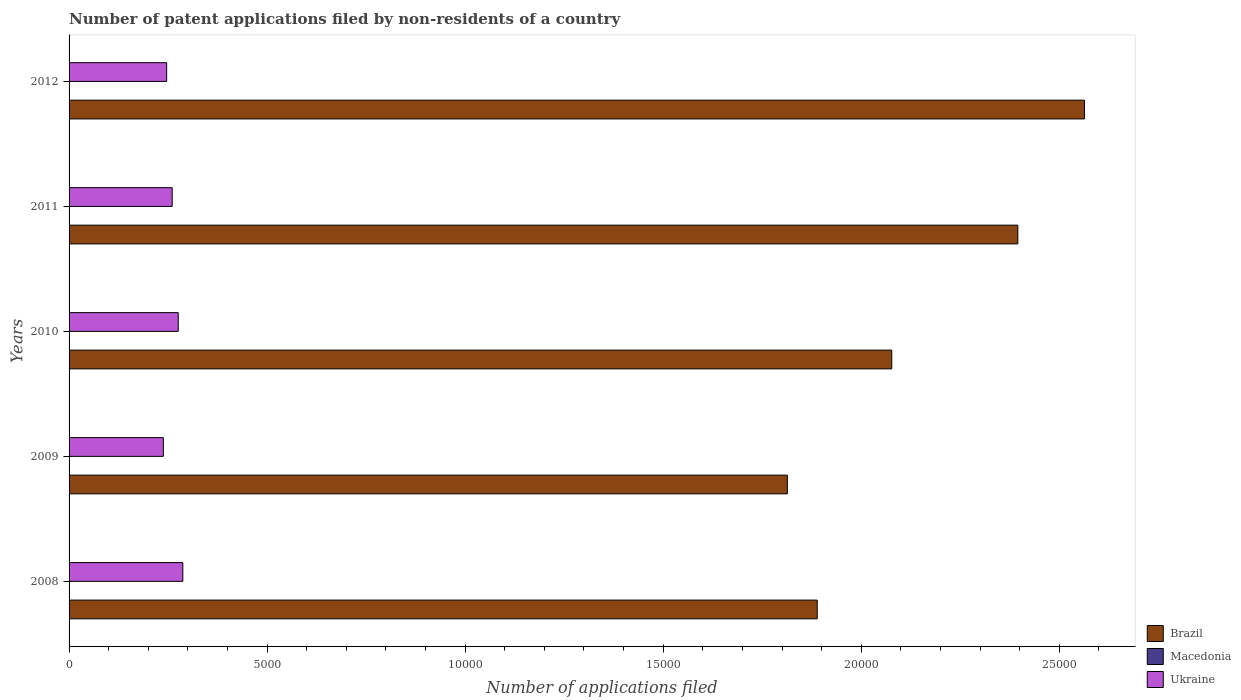How many groups of bars are there?
Provide a short and direct response. 5. How many bars are there on the 2nd tick from the bottom?
Give a very brief answer. 3. What is the label of the 2nd group of bars from the top?
Ensure brevity in your answer.  2011. In how many cases, is the number of bars for a given year not equal to the number of legend labels?
Keep it short and to the point. 0. What is the number of applications filed in Ukraine in 2009?
Offer a terse response. 2380. Across all years, what is the maximum number of applications filed in Ukraine?
Your answer should be very brief. 2872. In which year was the number of applications filed in Brazil maximum?
Give a very brief answer. 2012. In which year was the number of applications filed in Brazil minimum?
Your answer should be very brief. 2009. What is the difference between the number of applications filed in Ukraine in 2009 and that in 2011?
Ensure brevity in your answer.  -224. What is the difference between the number of applications filed in Ukraine in 2010 and the number of applications filed in Macedonia in 2011?
Your response must be concise. 2753. What is the average number of applications filed in Ukraine per year?
Offer a terse response. 2615.2. In the year 2009, what is the difference between the number of applications filed in Macedonia and number of applications filed in Brazil?
Provide a succinct answer. -1.81e+04. In how many years, is the number of applications filed in Ukraine greater than 10000 ?
Provide a succinct answer. 0. What is the ratio of the number of applications filed in Macedonia in 2008 to that in 2012?
Provide a short and direct response. 1.67. Is the sum of the number of applications filed in Macedonia in 2008 and 2011 greater than the maximum number of applications filed in Brazil across all years?
Keep it short and to the point. No. What does the 3rd bar from the top in 2011 represents?
Ensure brevity in your answer.  Brazil. What does the 2nd bar from the bottom in 2009 represents?
Give a very brief answer. Macedonia. Are all the bars in the graph horizontal?
Make the answer very short. Yes. Are the values on the major ticks of X-axis written in scientific E-notation?
Your answer should be very brief. No. Where does the legend appear in the graph?
Your response must be concise. Bottom right. How many legend labels are there?
Make the answer very short. 3. What is the title of the graph?
Provide a succinct answer. Number of patent applications filed by non-residents of a country. Does "Faeroe Islands" appear as one of the legend labels in the graph?
Make the answer very short. No. What is the label or title of the X-axis?
Your answer should be very brief. Number of applications filed. What is the Number of applications filed of Brazil in 2008?
Make the answer very short. 1.89e+04. What is the Number of applications filed in Macedonia in 2008?
Your answer should be very brief. 5. What is the Number of applications filed of Ukraine in 2008?
Your answer should be compact. 2872. What is the Number of applications filed of Brazil in 2009?
Your response must be concise. 1.81e+04. What is the Number of applications filed of Ukraine in 2009?
Provide a short and direct response. 2380. What is the Number of applications filed of Brazil in 2010?
Offer a very short reply. 2.08e+04. What is the Number of applications filed of Ukraine in 2010?
Provide a short and direct response. 2756. What is the Number of applications filed of Brazil in 2011?
Your answer should be compact. 2.40e+04. What is the Number of applications filed in Ukraine in 2011?
Offer a very short reply. 2604. What is the Number of applications filed in Brazil in 2012?
Provide a succinct answer. 2.56e+04. What is the Number of applications filed of Ukraine in 2012?
Your response must be concise. 2464. Across all years, what is the maximum Number of applications filed in Brazil?
Your response must be concise. 2.56e+04. Across all years, what is the maximum Number of applications filed in Macedonia?
Ensure brevity in your answer.  11. Across all years, what is the maximum Number of applications filed of Ukraine?
Ensure brevity in your answer.  2872. Across all years, what is the minimum Number of applications filed in Brazil?
Make the answer very short. 1.81e+04. Across all years, what is the minimum Number of applications filed of Ukraine?
Your answer should be compact. 2380. What is the total Number of applications filed of Brazil in the graph?
Offer a very short reply. 1.07e+05. What is the total Number of applications filed in Ukraine in the graph?
Ensure brevity in your answer.  1.31e+04. What is the difference between the Number of applications filed of Brazil in 2008 and that in 2009?
Ensure brevity in your answer.  755. What is the difference between the Number of applications filed of Macedonia in 2008 and that in 2009?
Ensure brevity in your answer.  -6. What is the difference between the Number of applications filed of Ukraine in 2008 and that in 2009?
Keep it short and to the point. 492. What is the difference between the Number of applications filed in Brazil in 2008 and that in 2010?
Provide a short and direct response. -1881. What is the difference between the Number of applications filed in Macedonia in 2008 and that in 2010?
Make the answer very short. 4. What is the difference between the Number of applications filed in Ukraine in 2008 and that in 2010?
Keep it short and to the point. 116. What is the difference between the Number of applications filed of Brazil in 2008 and that in 2011?
Offer a terse response. -5064. What is the difference between the Number of applications filed in Ukraine in 2008 and that in 2011?
Provide a succinct answer. 268. What is the difference between the Number of applications filed of Brazil in 2008 and that in 2012?
Provide a succinct answer. -6747. What is the difference between the Number of applications filed of Macedonia in 2008 and that in 2012?
Your response must be concise. 2. What is the difference between the Number of applications filed in Ukraine in 2008 and that in 2012?
Offer a terse response. 408. What is the difference between the Number of applications filed in Brazil in 2009 and that in 2010?
Provide a short and direct response. -2636. What is the difference between the Number of applications filed in Macedonia in 2009 and that in 2010?
Offer a very short reply. 10. What is the difference between the Number of applications filed of Ukraine in 2009 and that in 2010?
Offer a terse response. -376. What is the difference between the Number of applications filed of Brazil in 2009 and that in 2011?
Provide a short and direct response. -5819. What is the difference between the Number of applications filed of Ukraine in 2009 and that in 2011?
Keep it short and to the point. -224. What is the difference between the Number of applications filed in Brazil in 2009 and that in 2012?
Make the answer very short. -7502. What is the difference between the Number of applications filed in Ukraine in 2009 and that in 2012?
Provide a short and direct response. -84. What is the difference between the Number of applications filed in Brazil in 2010 and that in 2011?
Offer a very short reply. -3183. What is the difference between the Number of applications filed of Macedonia in 2010 and that in 2011?
Offer a very short reply. -2. What is the difference between the Number of applications filed of Ukraine in 2010 and that in 2011?
Your response must be concise. 152. What is the difference between the Number of applications filed in Brazil in 2010 and that in 2012?
Give a very brief answer. -4866. What is the difference between the Number of applications filed in Ukraine in 2010 and that in 2012?
Provide a short and direct response. 292. What is the difference between the Number of applications filed in Brazil in 2011 and that in 2012?
Make the answer very short. -1683. What is the difference between the Number of applications filed in Ukraine in 2011 and that in 2012?
Your response must be concise. 140. What is the difference between the Number of applications filed of Brazil in 2008 and the Number of applications filed of Macedonia in 2009?
Provide a short and direct response. 1.89e+04. What is the difference between the Number of applications filed in Brazil in 2008 and the Number of applications filed in Ukraine in 2009?
Ensure brevity in your answer.  1.65e+04. What is the difference between the Number of applications filed in Macedonia in 2008 and the Number of applications filed in Ukraine in 2009?
Your answer should be compact. -2375. What is the difference between the Number of applications filed of Brazil in 2008 and the Number of applications filed of Macedonia in 2010?
Keep it short and to the point. 1.89e+04. What is the difference between the Number of applications filed in Brazil in 2008 and the Number of applications filed in Ukraine in 2010?
Offer a very short reply. 1.61e+04. What is the difference between the Number of applications filed in Macedonia in 2008 and the Number of applications filed in Ukraine in 2010?
Ensure brevity in your answer.  -2751. What is the difference between the Number of applications filed in Brazil in 2008 and the Number of applications filed in Macedonia in 2011?
Your response must be concise. 1.89e+04. What is the difference between the Number of applications filed in Brazil in 2008 and the Number of applications filed in Ukraine in 2011?
Offer a very short reply. 1.63e+04. What is the difference between the Number of applications filed in Macedonia in 2008 and the Number of applications filed in Ukraine in 2011?
Provide a succinct answer. -2599. What is the difference between the Number of applications filed of Brazil in 2008 and the Number of applications filed of Macedonia in 2012?
Your answer should be very brief. 1.89e+04. What is the difference between the Number of applications filed in Brazil in 2008 and the Number of applications filed in Ukraine in 2012?
Provide a succinct answer. 1.64e+04. What is the difference between the Number of applications filed in Macedonia in 2008 and the Number of applications filed in Ukraine in 2012?
Ensure brevity in your answer.  -2459. What is the difference between the Number of applications filed of Brazil in 2009 and the Number of applications filed of Macedonia in 2010?
Offer a very short reply. 1.81e+04. What is the difference between the Number of applications filed in Brazil in 2009 and the Number of applications filed in Ukraine in 2010?
Your answer should be compact. 1.54e+04. What is the difference between the Number of applications filed in Macedonia in 2009 and the Number of applications filed in Ukraine in 2010?
Offer a very short reply. -2745. What is the difference between the Number of applications filed in Brazil in 2009 and the Number of applications filed in Macedonia in 2011?
Your response must be concise. 1.81e+04. What is the difference between the Number of applications filed of Brazil in 2009 and the Number of applications filed of Ukraine in 2011?
Offer a terse response. 1.55e+04. What is the difference between the Number of applications filed of Macedonia in 2009 and the Number of applications filed of Ukraine in 2011?
Provide a succinct answer. -2593. What is the difference between the Number of applications filed of Brazil in 2009 and the Number of applications filed of Macedonia in 2012?
Provide a succinct answer. 1.81e+04. What is the difference between the Number of applications filed of Brazil in 2009 and the Number of applications filed of Ukraine in 2012?
Make the answer very short. 1.57e+04. What is the difference between the Number of applications filed of Macedonia in 2009 and the Number of applications filed of Ukraine in 2012?
Ensure brevity in your answer.  -2453. What is the difference between the Number of applications filed of Brazil in 2010 and the Number of applications filed of Macedonia in 2011?
Keep it short and to the point. 2.08e+04. What is the difference between the Number of applications filed in Brazil in 2010 and the Number of applications filed in Ukraine in 2011?
Provide a short and direct response. 1.82e+04. What is the difference between the Number of applications filed of Macedonia in 2010 and the Number of applications filed of Ukraine in 2011?
Offer a terse response. -2603. What is the difference between the Number of applications filed of Brazil in 2010 and the Number of applications filed of Macedonia in 2012?
Offer a terse response. 2.08e+04. What is the difference between the Number of applications filed in Brazil in 2010 and the Number of applications filed in Ukraine in 2012?
Ensure brevity in your answer.  1.83e+04. What is the difference between the Number of applications filed in Macedonia in 2010 and the Number of applications filed in Ukraine in 2012?
Offer a very short reply. -2463. What is the difference between the Number of applications filed in Brazil in 2011 and the Number of applications filed in Macedonia in 2012?
Give a very brief answer. 2.40e+04. What is the difference between the Number of applications filed of Brazil in 2011 and the Number of applications filed of Ukraine in 2012?
Offer a terse response. 2.15e+04. What is the difference between the Number of applications filed of Macedonia in 2011 and the Number of applications filed of Ukraine in 2012?
Make the answer very short. -2461. What is the average Number of applications filed in Brazil per year?
Your answer should be very brief. 2.15e+04. What is the average Number of applications filed in Ukraine per year?
Your answer should be compact. 2615.2. In the year 2008, what is the difference between the Number of applications filed of Brazil and Number of applications filed of Macedonia?
Your response must be concise. 1.89e+04. In the year 2008, what is the difference between the Number of applications filed of Brazil and Number of applications filed of Ukraine?
Ensure brevity in your answer.  1.60e+04. In the year 2008, what is the difference between the Number of applications filed in Macedonia and Number of applications filed in Ukraine?
Your answer should be very brief. -2867. In the year 2009, what is the difference between the Number of applications filed in Brazil and Number of applications filed in Macedonia?
Make the answer very short. 1.81e+04. In the year 2009, what is the difference between the Number of applications filed in Brazil and Number of applications filed in Ukraine?
Offer a very short reply. 1.58e+04. In the year 2009, what is the difference between the Number of applications filed in Macedonia and Number of applications filed in Ukraine?
Your response must be concise. -2369. In the year 2010, what is the difference between the Number of applications filed of Brazil and Number of applications filed of Macedonia?
Provide a short and direct response. 2.08e+04. In the year 2010, what is the difference between the Number of applications filed in Brazil and Number of applications filed in Ukraine?
Offer a very short reply. 1.80e+04. In the year 2010, what is the difference between the Number of applications filed in Macedonia and Number of applications filed in Ukraine?
Offer a terse response. -2755. In the year 2011, what is the difference between the Number of applications filed of Brazil and Number of applications filed of Macedonia?
Make the answer very short. 2.40e+04. In the year 2011, what is the difference between the Number of applications filed in Brazil and Number of applications filed in Ukraine?
Provide a succinct answer. 2.14e+04. In the year 2011, what is the difference between the Number of applications filed in Macedonia and Number of applications filed in Ukraine?
Provide a succinct answer. -2601. In the year 2012, what is the difference between the Number of applications filed in Brazil and Number of applications filed in Macedonia?
Keep it short and to the point. 2.56e+04. In the year 2012, what is the difference between the Number of applications filed in Brazil and Number of applications filed in Ukraine?
Keep it short and to the point. 2.32e+04. In the year 2012, what is the difference between the Number of applications filed of Macedonia and Number of applications filed of Ukraine?
Your answer should be compact. -2461. What is the ratio of the Number of applications filed in Brazil in 2008 to that in 2009?
Ensure brevity in your answer.  1.04. What is the ratio of the Number of applications filed of Macedonia in 2008 to that in 2009?
Keep it short and to the point. 0.45. What is the ratio of the Number of applications filed in Ukraine in 2008 to that in 2009?
Your answer should be very brief. 1.21. What is the ratio of the Number of applications filed of Brazil in 2008 to that in 2010?
Provide a short and direct response. 0.91. What is the ratio of the Number of applications filed in Macedonia in 2008 to that in 2010?
Your answer should be very brief. 5. What is the ratio of the Number of applications filed of Ukraine in 2008 to that in 2010?
Give a very brief answer. 1.04. What is the ratio of the Number of applications filed in Brazil in 2008 to that in 2011?
Provide a succinct answer. 0.79. What is the ratio of the Number of applications filed of Macedonia in 2008 to that in 2011?
Make the answer very short. 1.67. What is the ratio of the Number of applications filed of Ukraine in 2008 to that in 2011?
Keep it short and to the point. 1.1. What is the ratio of the Number of applications filed in Brazil in 2008 to that in 2012?
Keep it short and to the point. 0.74. What is the ratio of the Number of applications filed in Ukraine in 2008 to that in 2012?
Your response must be concise. 1.17. What is the ratio of the Number of applications filed of Brazil in 2009 to that in 2010?
Keep it short and to the point. 0.87. What is the ratio of the Number of applications filed of Macedonia in 2009 to that in 2010?
Keep it short and to the point. 11. What is the ratio of the Number of applications filed of Ukraine in 2009 to that in 2010?
Your answer should be compact. 0.86. What is the ratio of the Number of applications filed in Brazil in 2009 to that in 2011?
Give a very brief answer. 0.76. What is the ratio of the Number of applications filed of Macedonia in 2009 to that in 2011?
Provide a succinct answer. 3.67. What is the ratio of the Number of applications filed of Ukraine in 2009 to that in 2011?
Your response must be concise. 0.91. What is the ratio of the Number of applications filed of Brazil in 2009 to that in 2012?
Keep it short and to the point. 0.71. What is the ratio of the Number of applications filed of Macedonia in 2009 to that in 2012?
Your answer should be very brief. 3.67. What is the ratio of the Number of applications filed in Ukraine in 2009 to that in 2012?
Provide a succinct answer. 0.97. What is the ratio of the Number of applications filed in Brazil in 2010 to that in 2011?
Provide a short and direct response. 0.87. What is the ratio of the Number of applications filed of Macedonia in 2010 to that in 2011?
Make the answer very short. 0.33. What is the ratio of the Number of applications filed in Ukraine in 2010 to that in 2011?
Your answer should be very brief. 1.06. What is the ratio of the Number of applications filed of Brazil in 2010 to that in 2012?
Ensure brevity in your answer.  0.81. What is the ratio of the Number of applications filed of Macedonia in 2010 to that in 2012?
Ensure brevity in your answer.  0.33. What is the ratio of the Number of applications filed in Ukraine in 2010 to that in 2012?
Provide a succinct answer. 1.12. What is the ratio of the Number of applications filed of Brazil in 2011 to that in 2012?
Your response must be concise. 0.93. What is the ratio of the Number of applications filed of Ukraine in 2011 to that in 2012?
Your response must be concise. 1.06. What is the difference between the highest and the second highest Number of applications filed in Brazil?
Give a very brief answer. 1683. What is the difference between the highest and the second highest Number of applications filed of Macedonia?
Offer a terse response. 6. What is the difference between the highest and the second highest Number of applications filed in Ukraine?
Your answer should be compact. 116. What is the difference between the highest and the lowest Number of applications filed of Brazil?
Provide a succinct answer. 7502. What is the difference between the highest and the lowest Number of applications filed in Macedonia?
Your answer should be compact. 10. What is the difference between the highest and the lowest Number of applications filed of Ukraine?
Keep it short and to the point. 492. 